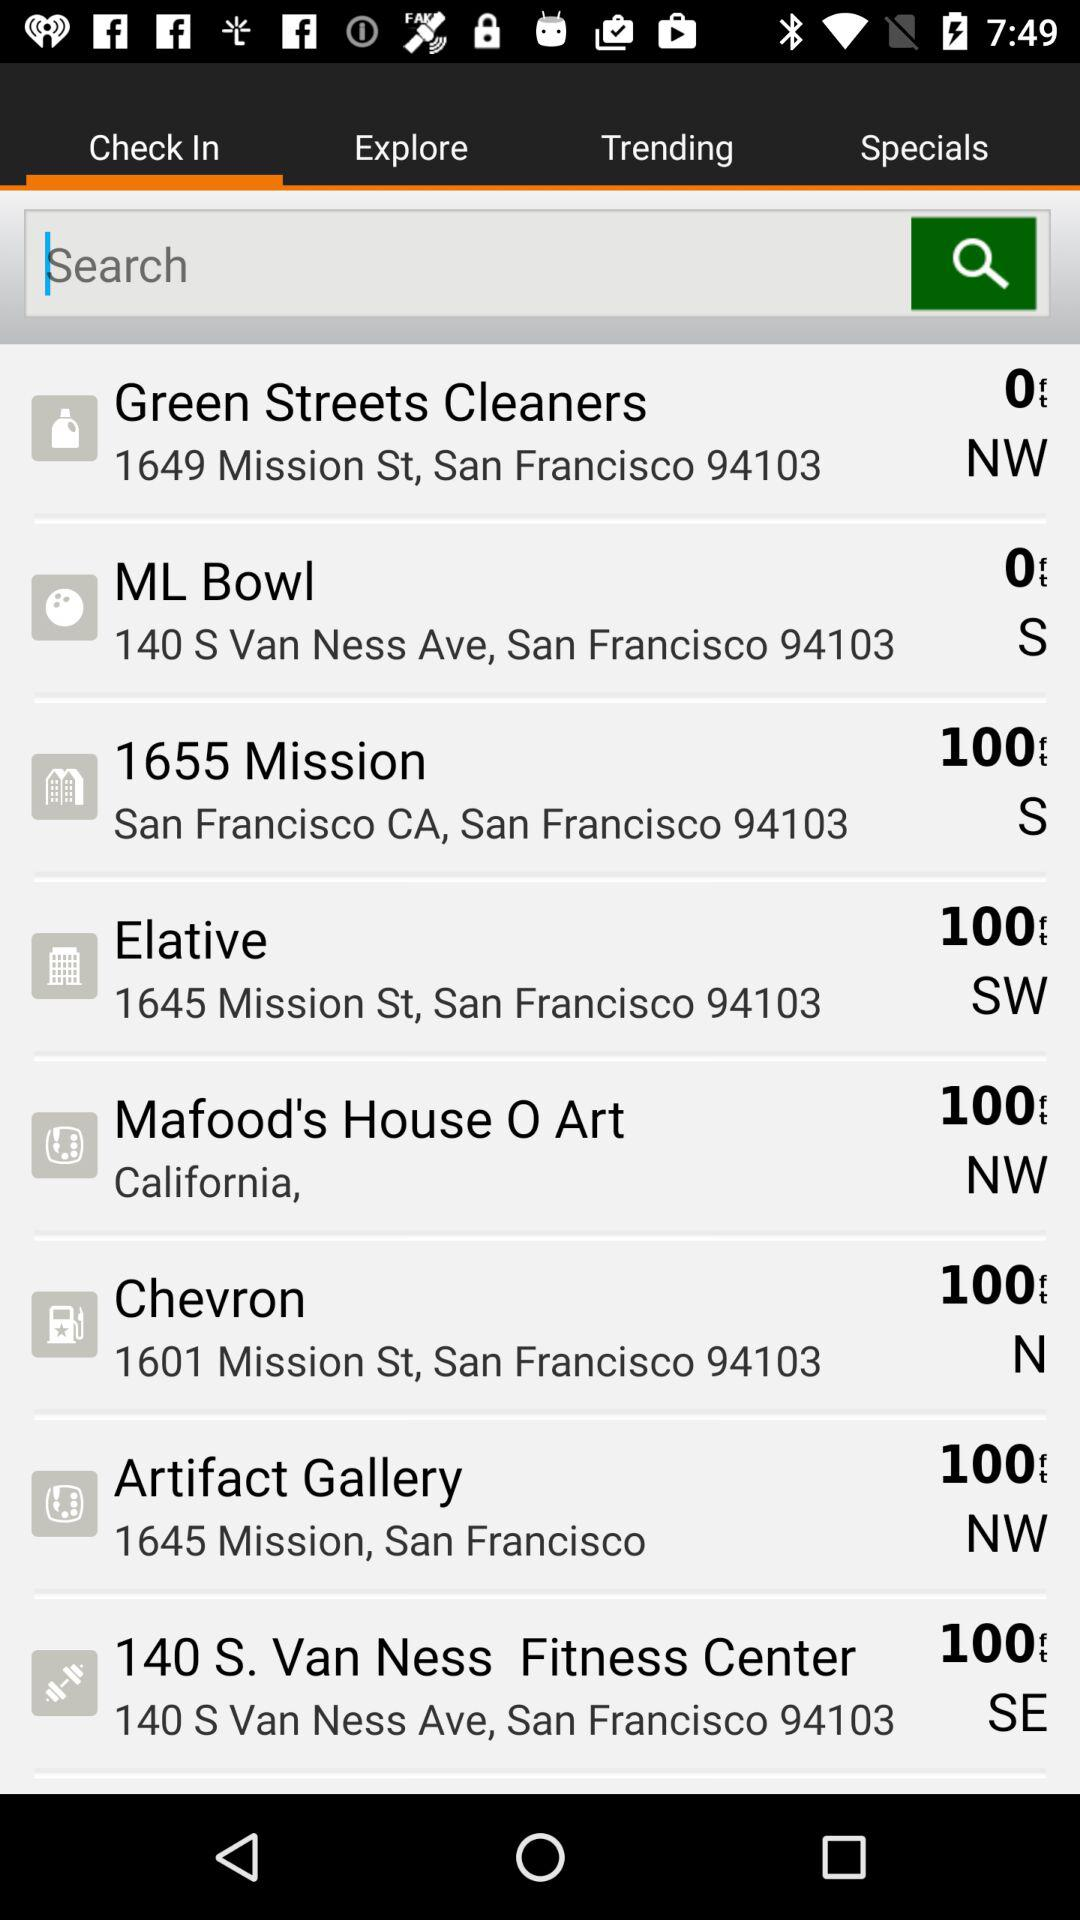Where is ML Bowl? ML Bowl is at 140 S Van Ness Ave, San Francisco, 94103. 